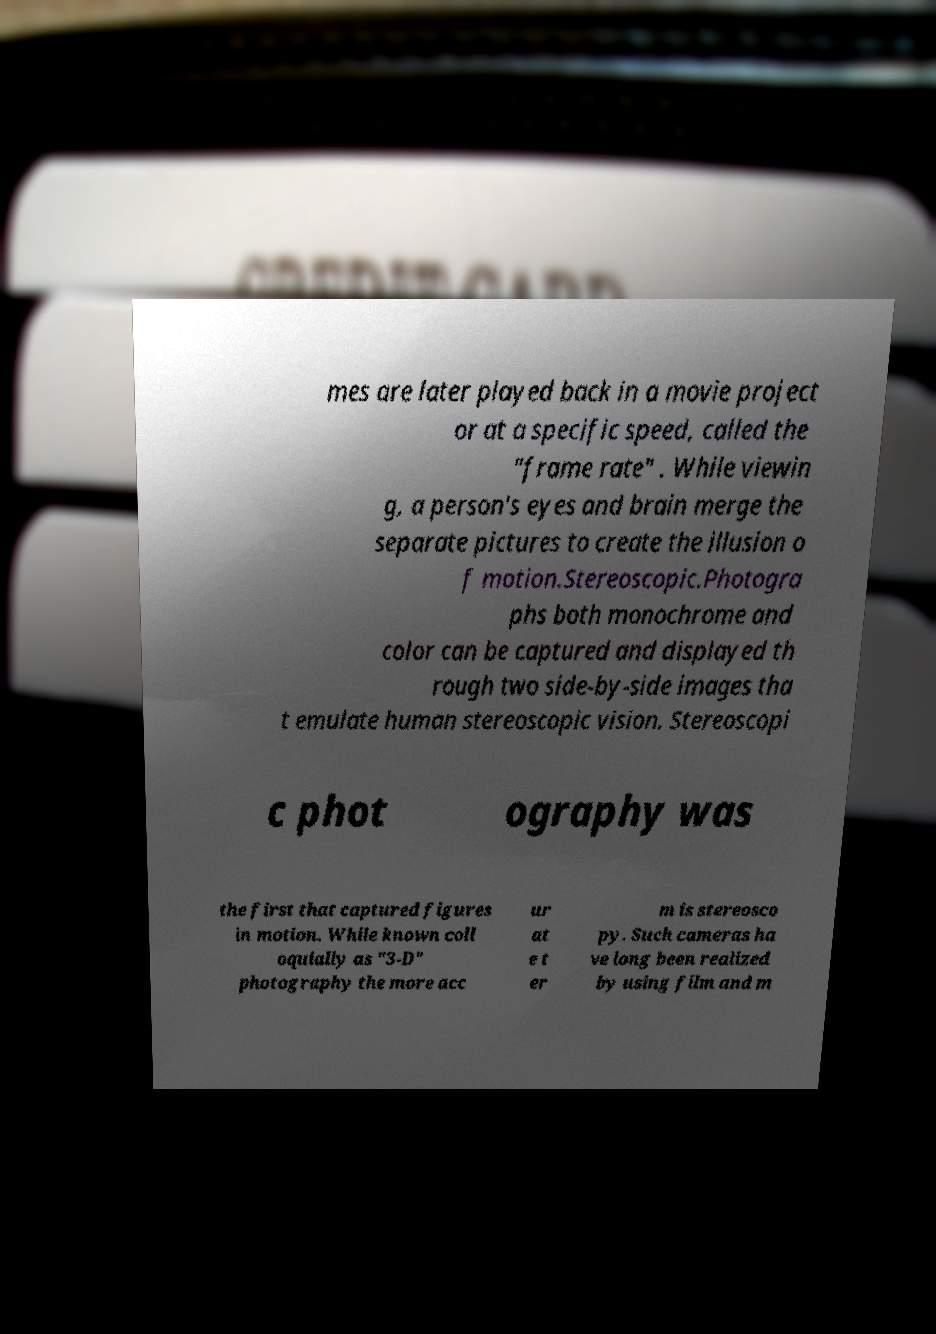Could you assist in decoding the text presented in this image and type it out clearly? mes are later played back in a movie project or at a specific speed, called the "frame rate" . While viewin g, a person's eyes and brain merge the separate pictures to create the illusion o f motion.Stereoscopic.Photogra phs both monochrome and color can be captured and displayed th rough two side-by-side images tha t emulate human stereoscopic vision. Stereoscopi c phot ography was the first that captured figures in motion. While known coll oquially as "3-D" photography the more acc ur at e t er m is stereosco py. Such cameras ha ve long been realized by using film and m 